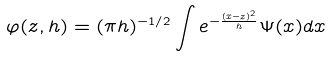<formula> <loc_0><loc_0><loc_500><loc_500>\varphi ( z , h ) = ( \pi h ) ^ { - 1 / 2 } \int e ^ { - \frac { ( x - z ) ^ { 2 } } h } \Psi ( x ) d x</formula> 